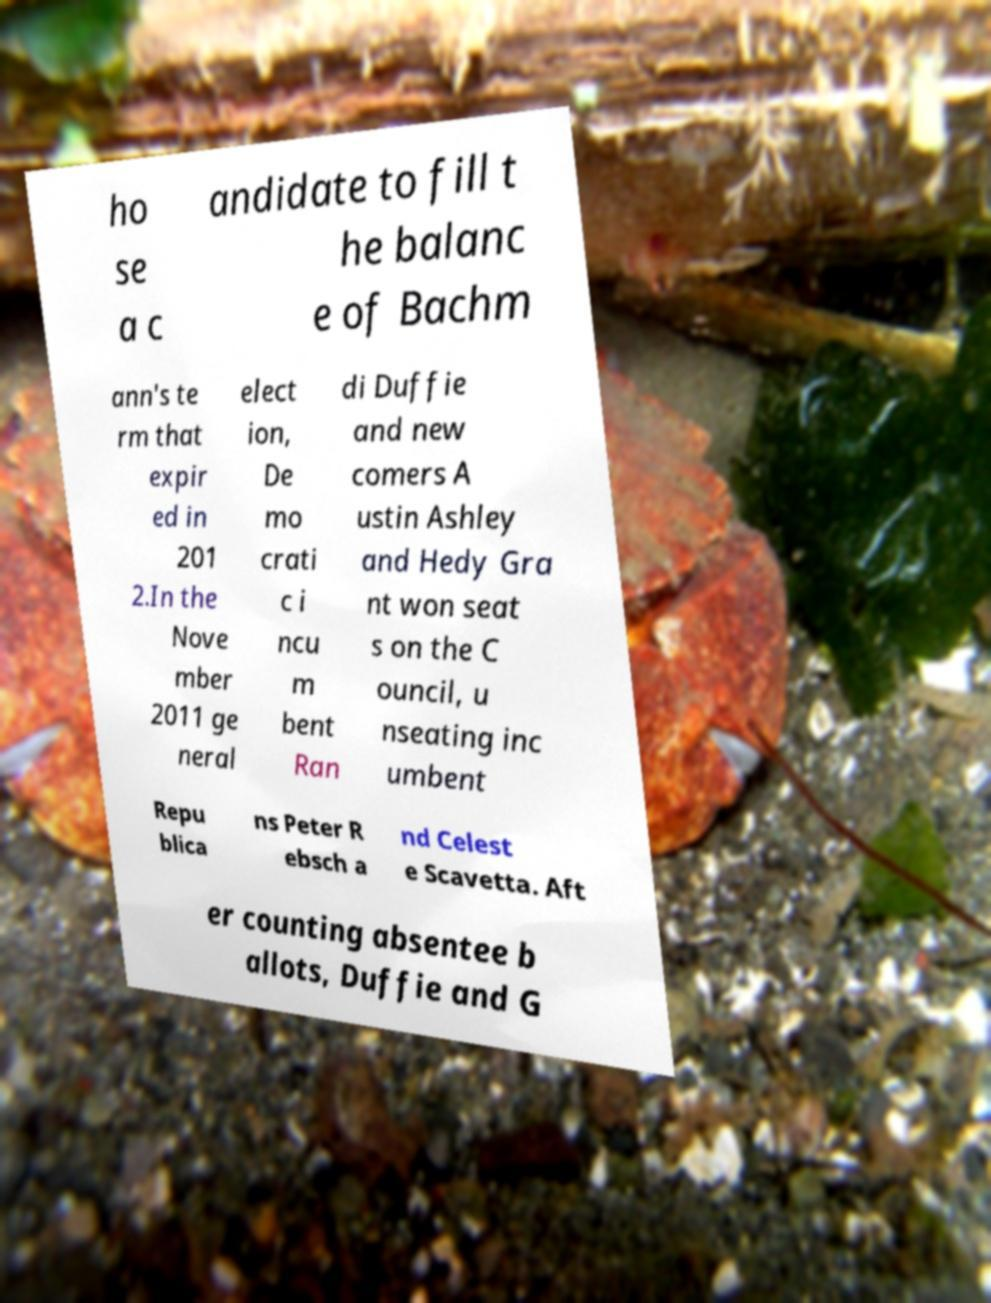Could you assist in decoding the text presented in this image and type it out clearly? ho se a c andidate to fill t he balanc e of Bachm ann's te rm that expir ed in 201 2.In the Nove mber 2011 ge neral elect ion, De mo crati c i ncu m bent Ran di Duffie and new comers A ustin Ashley and Hedy Gra nt won seat s on the C ouncil, u nseating inc umbent Repu blica ns Peter R ebsch a nd Celest e Scavetta. Aft er counting absentee b allots, Duffie and G 